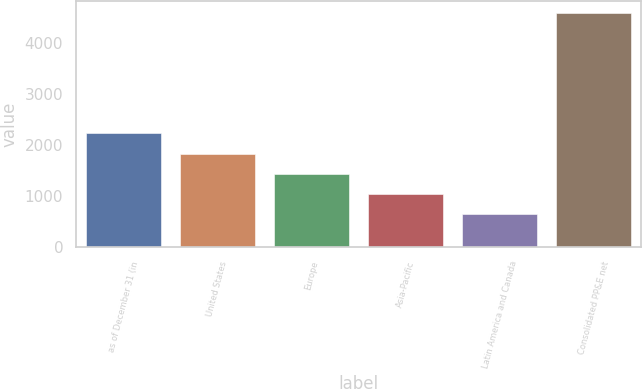Convert chart. <chart><loc_0><loc_0><loc_500><loc_500><bar_chart><fcel>as of December 31 (in<fcel>United States<fcel>Europe<fcel>Asia-Pacific<fcel>Latin America and Canada<fcel>Consolidated PP&E net<nl><fcel>2222.2<fcel>1827.9<fcel>1433.6<fcel>1039.3<fcel>645<fcel>4588<nl></chart> 